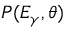<formula> <loc_0><loc_0><loc_500><loc_500>P ( E _ { \gamma } , \theta )</formula> 